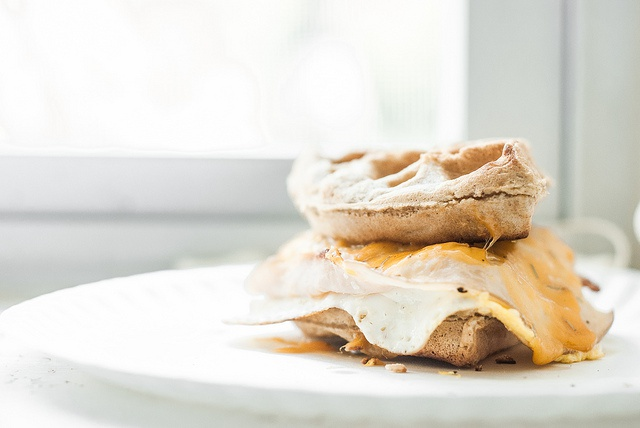Describe the objects in this image and their specific colors. I can see dining table in white, lightgray, darkgray, and maroon tones, sandwich in white, ivory, and tan tones, and chair in white, darkgray, and lightgray tones in this image. 